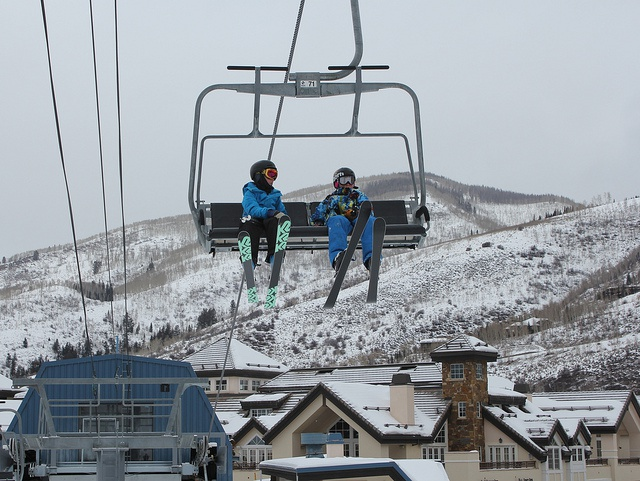Describe the objects in this image and their specific colors. I can see people in lightgray, black, blue, and gray tones, people in lightgray, black, teal, navy, and blue tones, skis in lightgray, black, gray, and purple tones, and skis in lightgray, purple, turquoise, and darkgray tones in this image. 